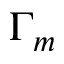<formula> <loc_0><loc_0><loc_500><loc_500>\Gamma _ { m }</formula> 